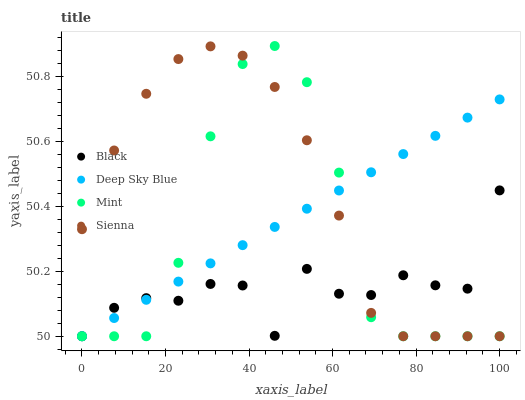Does Black have the minimum area under the curve?
Answer yes or no. Yes. Does Sienna have the maximum area under the curve?
Answer yes or no. Yes. Does Mint have the minimum area under the curve?
Answer yes or no. No. Does Mint have the maximum area under the curve?
Answer yes or no. No. Is Deep Sky Blue the smoothest?
Answer yes or no. Yes. Is Mint the roughest?
Answer yes or no. Yes. Is Black the smoothest?
Answer yes or no. No. Is Black the roughest?
Answer yes or no. No. Does Sienna have the lowest value?
Answer yes or no. Yes. Does Mint have the highest value?
Answer yes or no. Yes. Does Black have the highest value?
Answer yes or no. No. Does Black intersect Deep Sky Blue?
Answer yes or no. Yes. Is Black less than Deep Sky Blue?
Answer yes or no. No. Is Black greater than Deep Sky Blue?
Answer yes or no. No. 